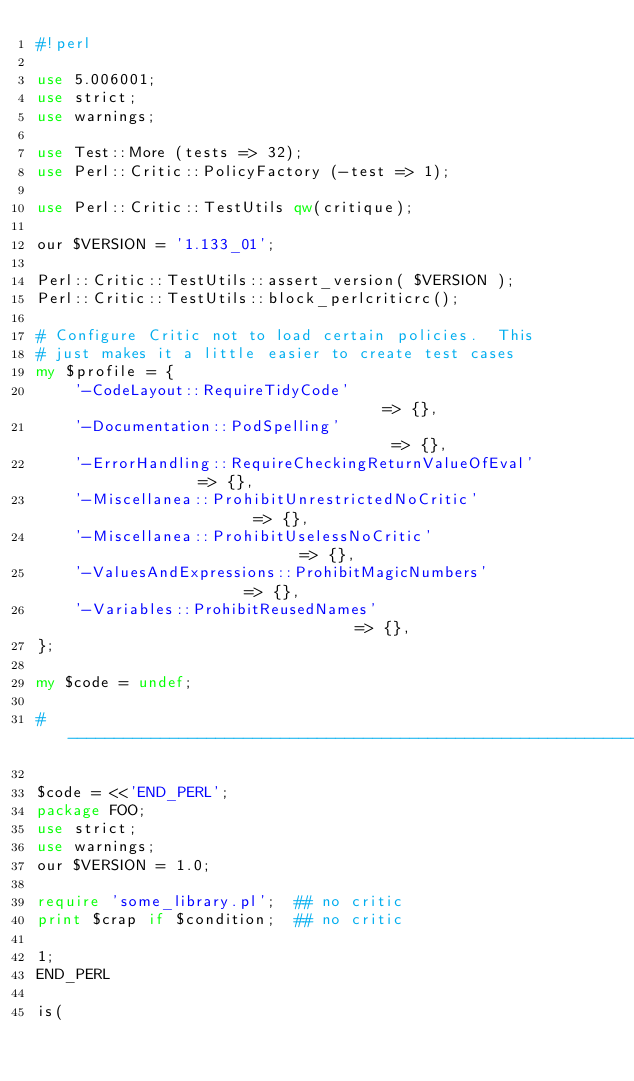<code> <loc_0><loc_0><loc_500><loc_500><_Perl_>#!perl

use 5.006001;
use strict;
use warnings;

use Test::More (tests => 32);
use Perl::Critic::PolicyFactory (-test => 1);

use Perl::Critic::TestUtils qw(critique);

our $VERSION = '1.133_01';

Perl::Critic::TestUtils::assert_version( $VERSION );
Perl::Critic::TestUtils::block_perlcriticrc();

# Configure Critic not to load certain policies.  This
# just makes it a little easier to create test cases
my $profile = {
    '-CodeLayout::RequireTidyCode'                               => {},
    '-Documentation::PodSpelling'                                => {},
    '-ErrorHandling::RequireCheckingReturnValueOfEval'           => {},
    '-Miscellanea::ProhibitUnrestrictedNoCritic'                 => {},
    '-Miscellanea::ProhibitUselessNoCritic'                      => {},
    '-ValuesAndExpressions::ProhibitMagicNumbers'                => {},
    '-Variables::ProhibitReusedNames'                            => {},
};

my $code = undef;

#-----------------------------------------------------------------------------

$code = <<'END_PERL';
package FOO;
use strict;
use warnings;
our $VERSION = 1.0;

require 'some_library.pl';  ## no critic
print $crap if $condition;  ## no critic

1;
END_PERL

is(</code> 